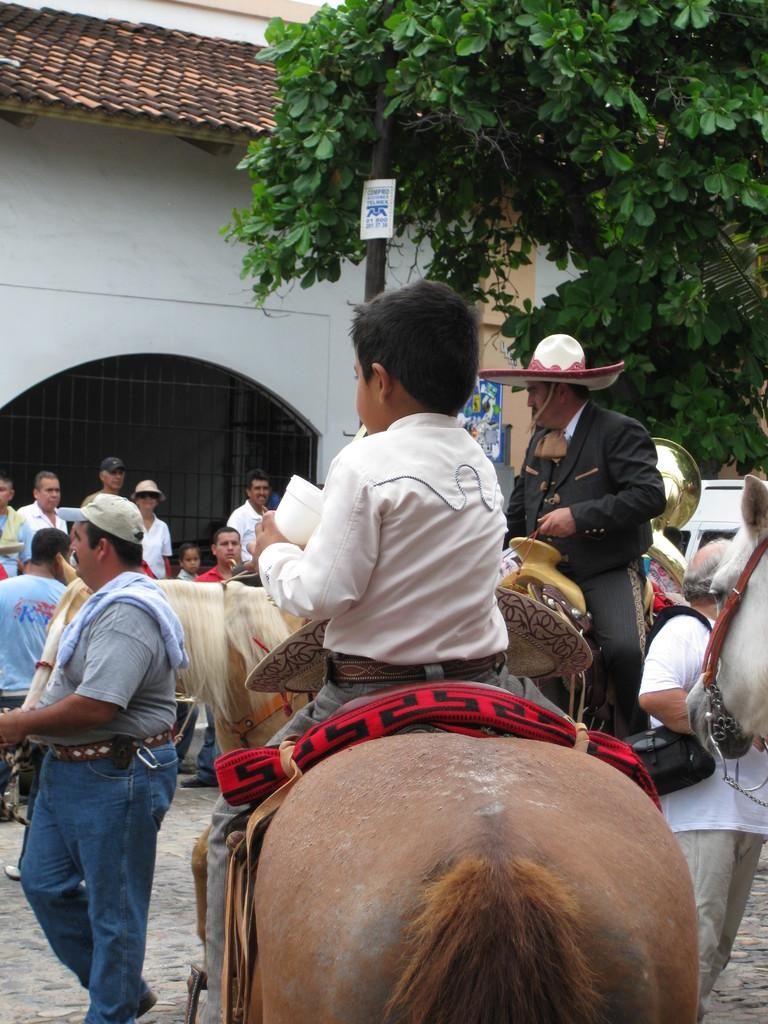Where was the image taken? The image was taken on a street. What is the boy doing in the image? The boy is sitting on a horse. What is the man on the left side of the image doing? The man is walking. What can be seen in the background of the image? There are people, at least one building, and a tree in the background of the image. What type of seat is the daughter using in the image? There is no daughter present in the image, and therefore no seat can be associated with her. 